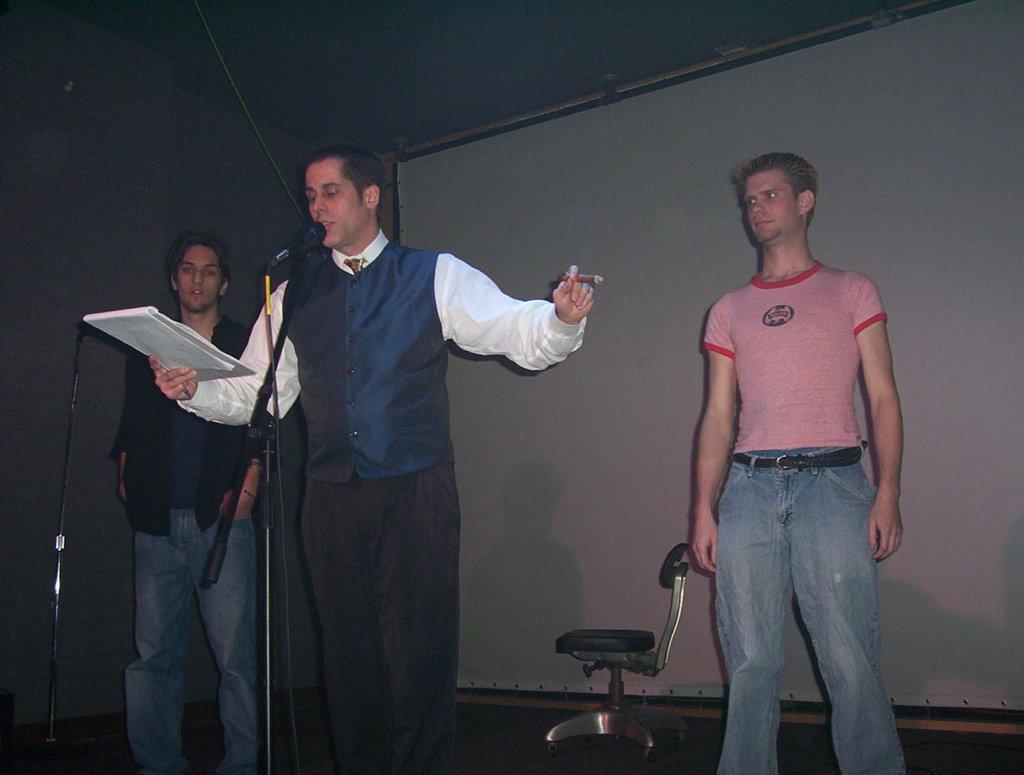Could you give a brief overview of what you see in this image? In the center of the image we can see three persons are standing and they are in different costumes. Among them, we can see one person is holding some objects. In front of them, we can see stands and one microphone. In the background there is a wall, chair and one board. 